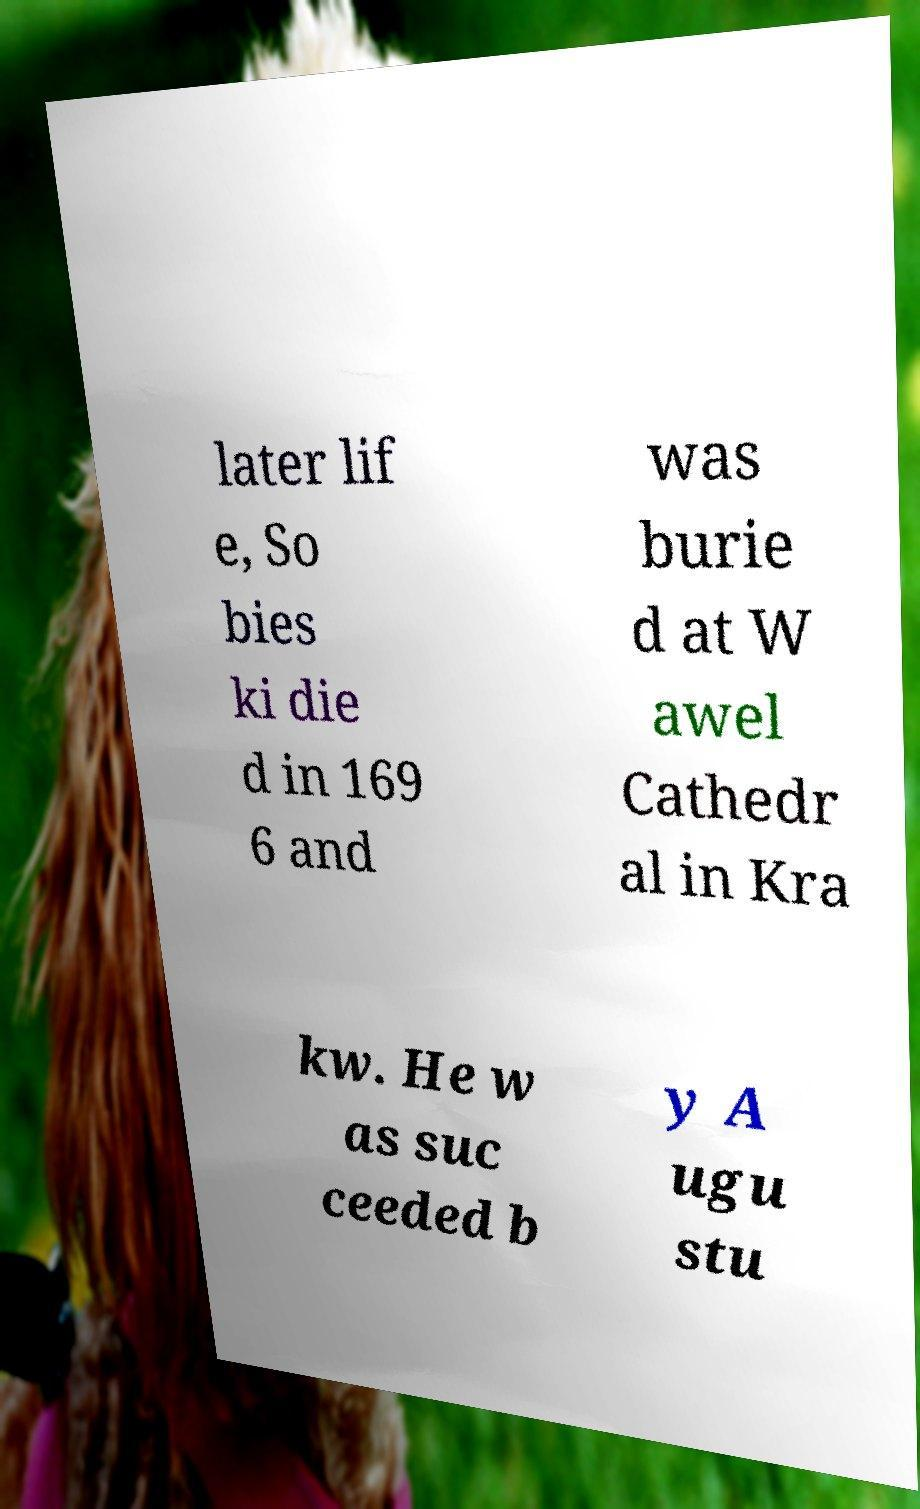For documentation purposes, I need the text within this image transcribed. Could you provide that? later lif e, So bies ki die d in 169 6 and was burie d at W awel Cathedr al in Kra kw. He w as suc ceeded b y A ugu stu 